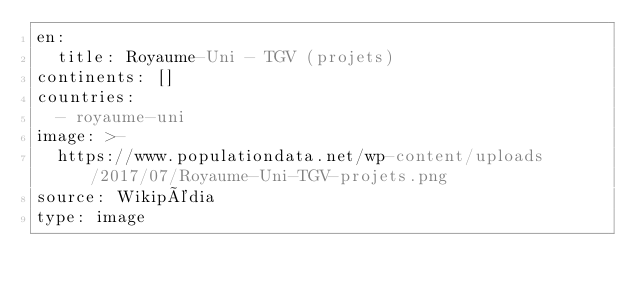Convert code to text. <code><loc_0><loc_0><loc_500><loc_500><_YAML_>en:
  title: Royaume-Uni - TGV (projets)
continents: []
countries:
  - royaume-uni
image: >-
  https://www.populationdata.net/wp-content/uploads/2017/07/Royaume-Uni-TGV-projets.png
source: Wikipédia
type: image
</code> 